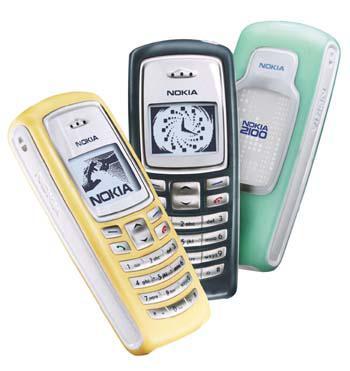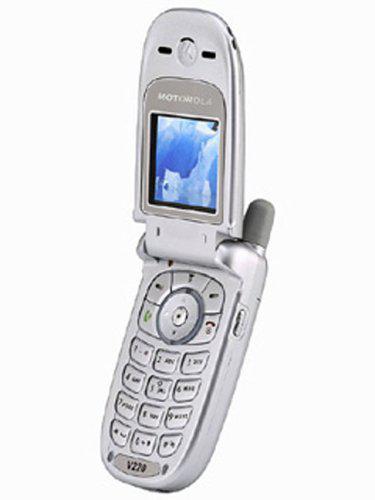The first image is the image on the left, the second image is the image on the right. Examine the images to the left and right. Is the description "There are more phones in the image on the right." accurate? Answer yes or no. No. The first image is the image on the left, the second image is the image on the right. Given the left and right images, does the statement "The right image shows an opened flip phone." hold true? Answer yes or no. Yes. 